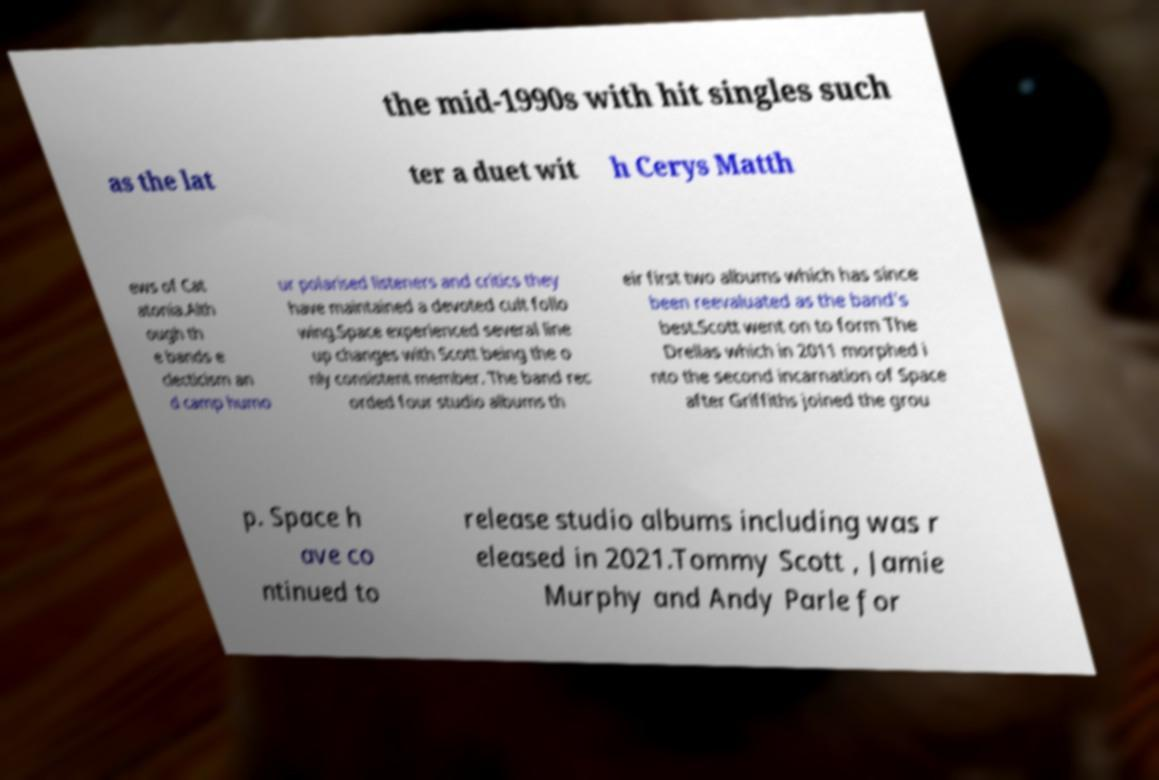I need the written content from this picture converted into text. Can you do that? the mid-1990s with hit singles such as the lat ter a duet wit h Cerys Matth ews of Cat atonia.Alth ough th e bands e clecticism an d camp humo ur polarised listeners and critics they have maintained a devoted cult follo wing.Space experienced several line up changes with Scott being the o nly consistent member. The band rec orded four studio albums th eir first two albums which has since been reevaluated as the band's best.Scott went on to form The Drellas which in 2011 morphed i nto the second incarnation of Space after Griffiths joined the grou p. Space h ave co ntinued to release studio albums including was r eleased in 2021.Tommy Scott , Jamie Murphy and Andy Parle for 